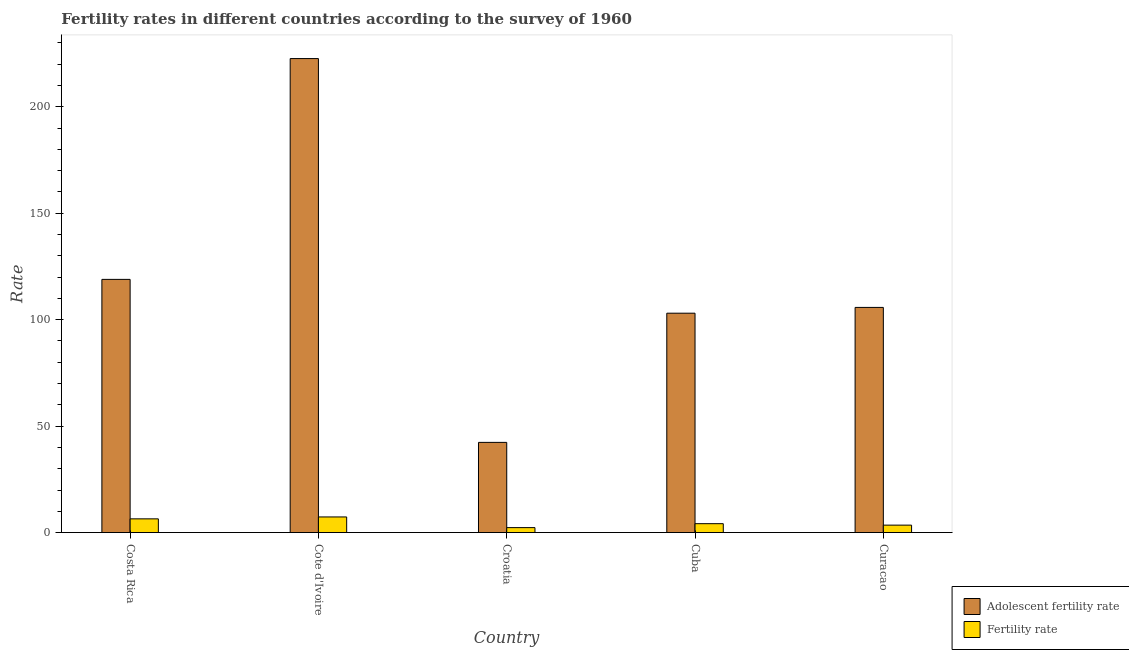How many bars are there on the 4th tick from the left?
Provide a short and direct response. 2. What is the label of the 4th group of bars from the left?
Provide a short and direct response. Cuba. What is the adolescent fertility rate in Cote d'Ivoire?
Make the answer very short. 222.62. Across all countries, what is the maximum adolescent fertility rate?
Your response must be concise. 222.62. Across all countries, what is the minimum fertility rate?
Your answer should be compact. 2.33. In which country was the adolescent fertility rate maximum?
Your response must be concise. Cote d'Ivoire. In which country was the fertility rate minimum?
Your response must be concise. Croatia. What is the total adolescent fertility rate in the graph?
Make the answer very short. 592.7. What is the difference between the adolescent fertility rate in Cuba and that in Curacao?
Your response must be concise. -2.71. What is the difference between the adolescent fertility rate in Croatia and the fertility rate in Costa Rica?
Offer a very short reply. 35.92. What is the average adolescent fertility rate per country?
Offer a terse response. 118.54. What is the difference between the fertility rate and adolescent fertility rate in Cuba?
Keep it short and to the point. -98.86. What is the ratio of the fertility rate in Costa Rica to that in Curacao?
Provide a succinct answer. 1.84. Is the fertility rate in Cote d'Ivoire less than that in Curacao?
Offer a very short reply. No. What is the difference between the highest and the second highest fertility rate?
Give a very brief answer. 0.9. What is the difference between the highest and the lowest fertility rate?
Your response must be concise. 5.02. In how many countries, is the adolescent fertility rate greater than the average adolescent fertility rate taken over all countries?
Keep it short and to the point. 2. What does the 1st bar from the left in Cote d'Ivoire represents?
Keep it short and to the point. Adolescent fertility rate. What does the 2nd bar from the right in Costa Rica represents?
Give a very brief answer. Adolescent fertility rate. Are all the bars in the graph horizontal?
Keep it short and to the point. No. Are the values on the major ticks of Y-axis written in scientific E-notation?
Make the answer very short. No. Where does the legend appear in the graph?
Ensure brevity in your answer.  Bottom right. What is the title of the graph?
Offer a terse response. Fertility rates in different countries according to the survey of 1960. What is the label or title of the X-axis?
Keep it short and to the point. Country. What is the label or title of the Y-axis?
Ensure brevity in your answer.  Rate. What is the Rate in Adolescent fertility rate in Costa Rica?
Ensure brevity in your answer.  118.92. What is the Rate in Fertility rate in Costa Rica?
Keep it short and to the point. 6.45. What is the Rate in Adolescent fertility rate in Cote d'Ivoire?
Your answer should be very brief. 222.62. What is the Rate in Fertility rate in Cote d'Ivoire?
Provide a succinct answer. 7.35. What is the Rate of Adolescent fertility rate in Croatia?
Give a very brief answer. 42.37. What is the Rate in Fertility rate in Croatia?
Provide a short and direct response. 2.33. What is the Rate in Adolescent fertility rate in Cuba?
Your answer should be very brief. 103.04. What is the Rate of Fertility rate in Cuba?
Offer a very short reply. 4.18. What is the Rate of Adolescent fertility rate in Curacao?
Make the answer very short. 105.75. What is the Rate of Fertility rate in Curacao?
Your answer should be very brief. 3.5. Across all countries, what is the maximum Rate in Adolescent fertility rate?
Offer a terse response. 222.62. Across all countries, what is the maximum Rate in Fertility rate?
Make the answer very short. 7.35. Across all countries, what is the minimum Rate of Adolescent fertility rate?
Your answer should be compact. 42.37. Across all countries, what is the minimum Rate in Fertility rate?
Provide a short and direct response. 2.33. What is the total Rate of Adolescent fertility rate in the graph?
Your response must be concise. 592.7. What is the total Rate in Fertility rate in the graph?
Provide a short and direct response. 23.82. What is the difference between the Rate in Adolescent fertility rate in Costa Rica and that in Cote d'Ivoire?
Make the answer very short. -103.7. What is the difference between the Rate of Fertility rate in Costa Rica and that in Cote d'Ivoire?
Your answer should be very brief. -0.9. What is the difference between the Rate in Adolescent fertility rate in Costa Rica and that in Croatia?
Keep it short and to the point. 76.55. What is the difference between the Rate in Fertility rate in Costa Rica and that in Croatia?
Your answer should be compact. 4.12. What is the difference between the Rate of Adolescent fertility rate in Costa Rica and that in Cuba?
Your answer should be compact. 15.88. What is the difference between the Rate in Fertility rate in Costa Rica and that in Cuba?
Ensure brevity in your answer.  2.27. What is the difference between the Rate in Adolescent fertility rate in Costa Rica and that in Curacao?
Provide a succinct answer. 13.16. What is the difference between the Rate in Fertility rate in Costa Rica and that in Curacao?
Make the answer very short. 2.95. What is the difference between the Rate in Adolescent fertility rate in Cote d'Ivoire and that in Croatia?
Keep it short and to the point. 180.25. What is the difference between the Rate of Fertility rate in Cote d'Ivoire and that in Croatia?
Offer a very short reply. 5.02. What is the difference between the Rate of Adolescent fertility rate in Cote d'Ivoire and that in Cuba?
Provide a succinct answer. 119.58. What is the difference between the Rate of Fertility rate in Cote d'Ivoire and that in Cuba?
Your answer should be very brief. 3.17. What is the difference between the Rate of Adolescent fertility rate in Cote d'Ivoire and that in Curacao?
Your answer should be compact. 116.86. What is the difference between the Rate of Fertility rate in Cote d'Ivoire and that in Curacao?
Provide a succinct answer. 3.85. What is the difference between the Rate of Adolescent fertility rate in Croatia and that in Cuba?
Give a very brief answer. -60.67. What is the difference between the Rate in Fertility rate in Croatia and that in Cuba?
Your response must be concise. -1.85. What is the difference between the Rate of Adolescent fertility rate in Croatia and that in Curacao?
Provide a short and direct response. -63.39. What is the difference between the Rate of Fertility rate in Croatia and that in Curacao?
Ensure brevity in your answer.  -1.17. What is the difference between the Rate in Adolescent fertility rate in Cuba and that in Curacao?
Provide a short and direct response. -2.71. What is the difference between the Rate in Fertility rate in Cuba and that in Curacao?
Provide a succinct answer. 0.68. What is the difference between the Rate of Adolescent fertility rate in Costa Rica and the Rate of Fertility rate in Cote d'Ivoire?
Keep it short and to the point. 111.57. What is the difference between the Rate in Adolescent fertility rate in Costa Rica and the Rate in Fertility rate in Croatia?
Give a very brief answer. 116.59. What is the difference between the Rate in Adolescent fertility rate in Costa Rica and the Rate in Fertility rate in Cuba?
Provide a short and direct response. 114.74. What is the difference between the Rate of Adolescent fertility rate in Costa Rica and the Rate of Fertility rate in Curacao?
Your answer should be very brief. 115.42. What is the difference between the Rate of Adolescent fertility rate in Cote d'Ivoire and the Rate of Fertility rate in Croatia?
Your response must be concise. 220.28. What is the difference between the Rate of Adolescent fertility rate in Cote d'Ivoire and the Rate of Fertility rate in Cuba?
Offer a terse response. 218.43. What is the difference between the Rate of Adolescent fertility rate in Cote d'Ivoire and the Rate of Fertility rate in Curacao?
Keep it short and to the point. 219.12. What is the difference between the Rate in Adolescent fertility rate in Croatia and the Rate in Fertility rate in Cuba?
Offer a terse response. 38.19. What is the difference between the Rate of Adolescent fertility rate in Croatia and the Rate of Fertility rate in Curacao?
Keep it short and to the point. 38.87. What is the difference between the Rate of Adolescent fertility rate in Cuba and the Rate of Fertility rate in Curacao?
Provide a succinct answer. 99.54. What is the average Rate of Adolescent fertility rate per country?
Make the answer very short. 118.54. What is the average Rate in Fertility rate per country?
Your answer should be compact. 4.76. What is the difference between the Rate of Adolescent fertility rate and Rate of Fertility rate in Costa Rica?
Provide a succinct answer. 112.47. What is the difference between the Rate in Adolescent fertility rate and Rate in Fertility rate in Cote d'Ivoire?
Offer a terse response. 215.27. What is the difference between the Rate of Adolescent fertility rate and Rate of Fertility rate in Croatia?
Keep it short and to the point. 40.04. What is the difference between the Rate in Adolescent fertility rate and Rate in Fertility rate in Cuba?
Provide a short and direct response. 98.86. What is the difference between the Rate of Adolescent fertility rate and Rate of Fertility rate in Curacao?
Keep it short and to the point. 102.25. What is the ratio of the Rate in Adolescent fertility rate in Costa Rica to that in Cote d'Ivoire?
Provide a short and direct response. 0.53. What is the ratio of the Rate of Fertility rate in Costa Rica to that in Cote d'Ivoire?
Give a very brief answer. 0.88. What is the ratio of the Rate of Adolescent fertility rate in Costa Rica to that in Croatia?
Give a very brief answer. 2.81. What is the ratio of the Rate in Fertility rate in Costa Rica to that in Croatia?
Your response must be concise. 2.77. What is the ratio of the Rate of Adolescent fertility rate in Costa Rica to that in Cuba?
Offer a very short reply. 1.15. What is the ratio of the Rate in Fertility rate in Costa Rica to that in Cuba?
Keep it short and to the point. 1.54. What is the ratio of the Rate in Adolescent fertility rate in Costa Rica to that in Curacao?
Offer a very short reply. 1.12. What is the ratio of the Rate in Fertility rate in Costa Rica to that in Curacao?
Make the answer very short. 1.84. What is the ratio of the Rate of Adolescent fertility rate in Cote d'Ivoire to that in Croatia?
Give a very brief answer. 5.25. What is the ratio of the Rate of Fertility rate in Cote d'Ivoire to that in Croatia?
Give a very brief answer. 3.15. What is the ratio of the Rate in Adolescent fertility rate in Cote d'Ivoire to that in Cuba?
Your answer should be very brief. 2.16. What is the ratio of the Rate in Fertility rate in Cote d'Ivoire to that in Cuba?
Keep it short and to the point. 1.76. What is the ratio of the Rate of Adolescent fertility rate in Cote d'Ivoire to that in Curacao?
Your answer should be compact. 2.1. What is the ratio of the Rate in Fertility rate in Cote d'Ivoire to that in Curacao?
Your response must be concise. 2.1. What is the ratio of the Rate in Adolescent fertility rate in Croatia to that in Cuba?
Give a very brief answer. 0.41. What is the ratio of the Rate of Fertility rate in Croatia to that in Cuba?
Provide a succinct answer. 0.56. What is the ratio of the Rate of Adolescent fertility rate in Croatia to that in Curacao?
Give a very brief answer. 0.4. What is the ratio of the Rate of Fertility rate in Croatia to that in Curacao?
Make the answer very short. 0.67. What is the ratio of the Rate of Adolescent fertility rate in Cuba to that in Curacao?
Give a very brief answer. 0.97. What is the ratio of the Rate of Fertility rate in Cuba to that in Curacao?
Your response must be concise. 1.19. What is the difference between the highest and the second highest Rate of Adolescent fertility rate?
Keep it short and to the point. 103.7. What is the difference between the highest and the second highest Rate in Fertility rate?
Make the answer very short. 0.9. What is the difference between the highest and the lowest Rate of Adolescent fertility rate?
Provide a short and direct response. 180.25. What is the difference between the highest and the lowest Rate in Fertility rate?
Your response must be concise. 5.02. 